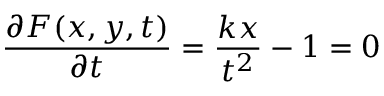Convert formula to latex. <formula><loc_0><loc_0><loc_500><loc_500>{ \frac { \partial F ( x , y , t ) } { \partial t } } = { \frac { k x } { t ^ { 2 } } } - 1 = 0</formula> 